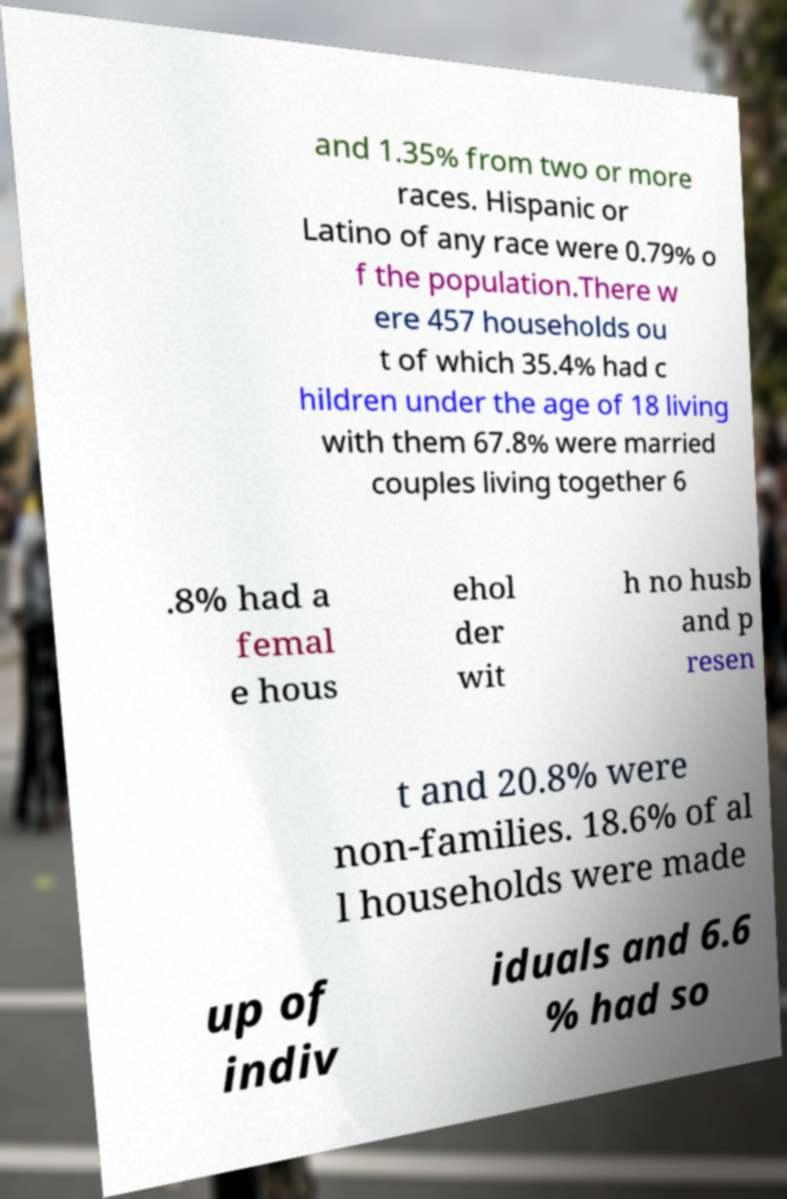Please identify and transcribe the text found in this image. and 1.35% from two or more races. Hispanic or Latino of any race were 0.79% o f the population.There w ere 457 households ou t of which 35.4% had c hildren under the age of 18 living with them 67.8% were married couples living together 6 .8% had a femal e hous ehol der wit h no husb and p resen t and 20.8% were non-families. 18.6% of al l households were made up of indiv iduals and 6.6 % had so 